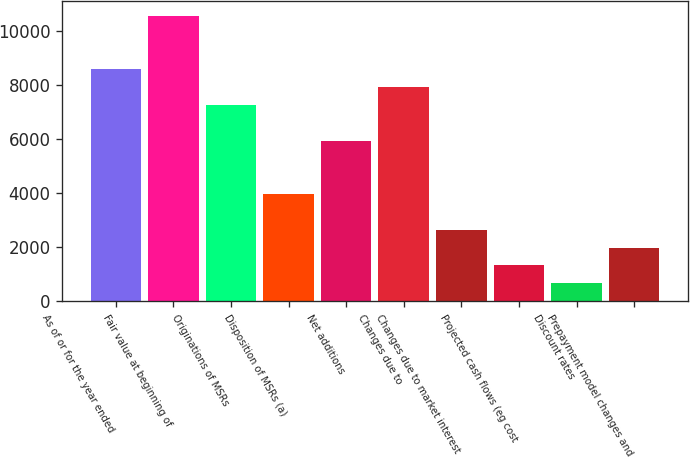<chart> <loc_0><loc_0><loc_500><loc_500><bar_chart><fcel>As of or for the year ended<fcel>Fair value at beginning of<fcel>Originations of MSRs<fcel>Disposition of MSRs (a)<fcel>Net additions<fcel>Changes due to<fcel>Changes due to market interest<fcel>Projected cash flows (eg cost<fcel>Discount rates<fcel>Prepayment model changes and<nl><fcel>8588.99<fcel>10570<fcel>7268.33<fcel>3966.68<fcel>5947.67<fcel>7928.66<fcel>2646.02<fcel>1325.36<fcel>665.03<fcel>1985.69<nl></chart> 